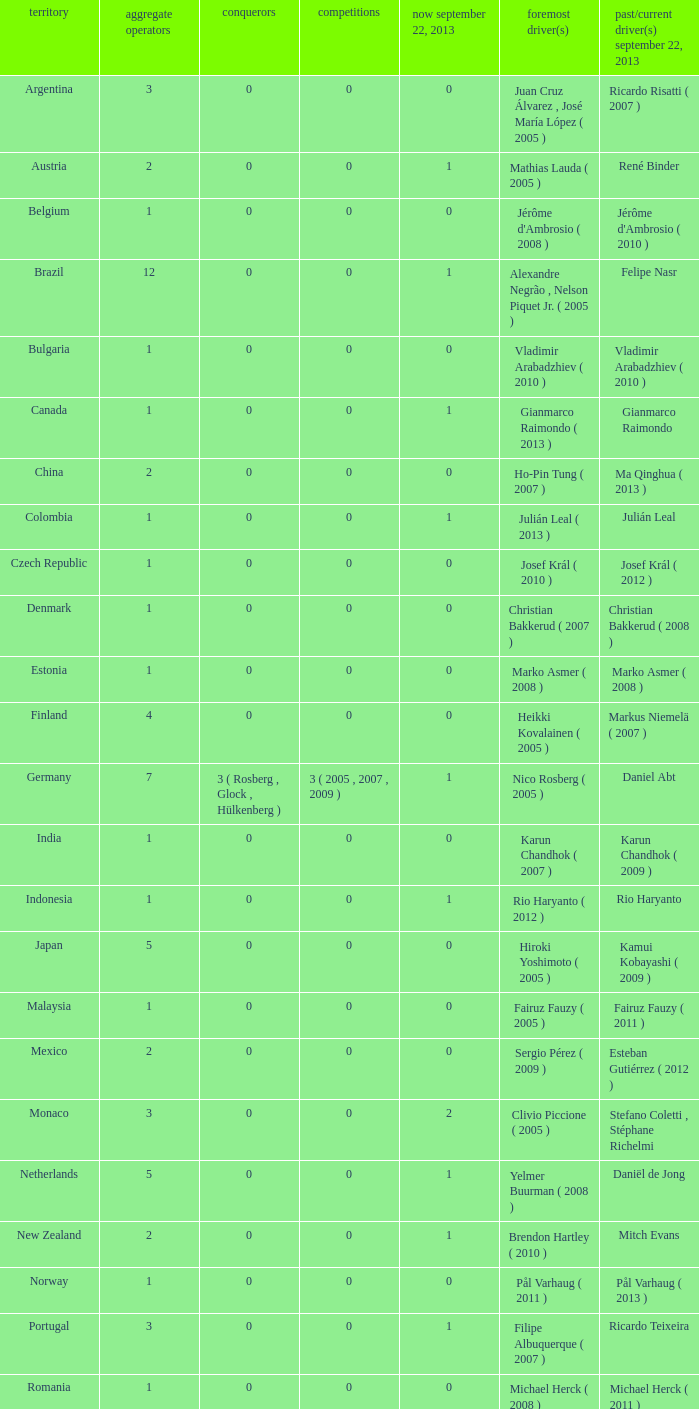How many champions were there when the first driver was hiroki yoshimoto ( 2005 )? 0.0. 